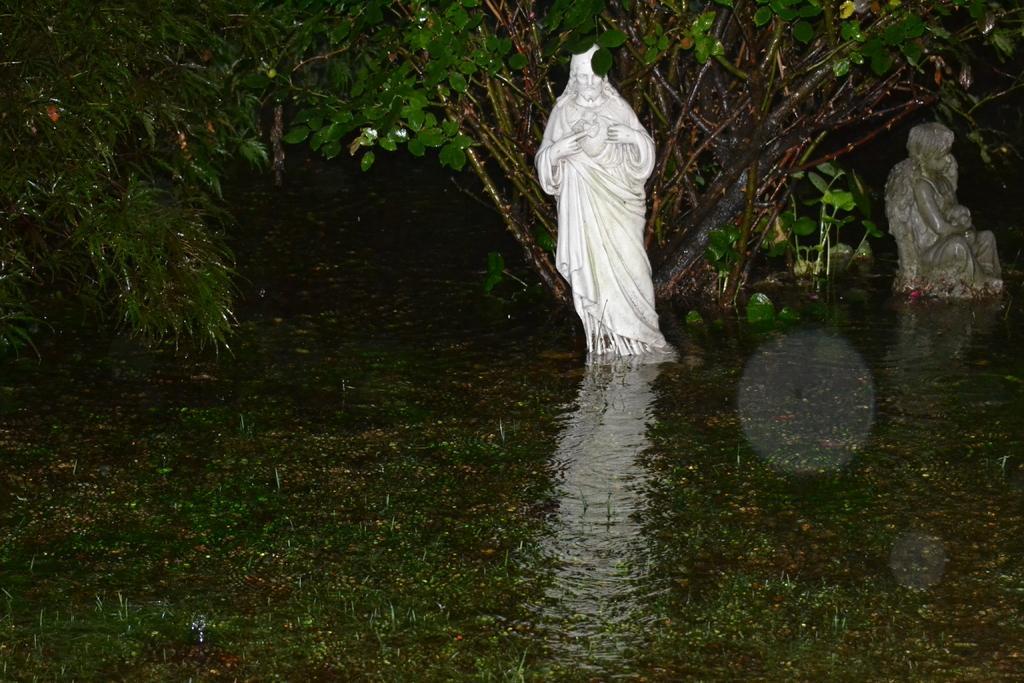In one or two sentences, can you explain what this image depicts? In this picture we can see statues in the middle of a river under a tree. 